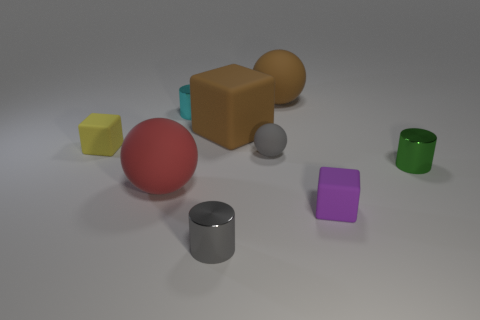Subtract all tiny purple cubes. How many cubes are left? 2 Add 1 big red things. How many objects exist? 10 Subtract 1 cylinders. How many cylinders are left? 2 Subtract all gray spheres. How many spheres are left? 2 Subtract all cylinders. How many objects are left? 6 Add 2 large rubber balls. How many large rubber balls are left? 4 Add 5 purple metallic cubes. How many purple metallic cubes exist? 5 Subtract 1 gray balls. How many objects are left? 8 Subtract all blue cubes. Subtract all blue balls. How many cubes are left? 3 Subtract all cyan shiny blocks. Subtract all tiny purple matte things. How many objects are left? 8 